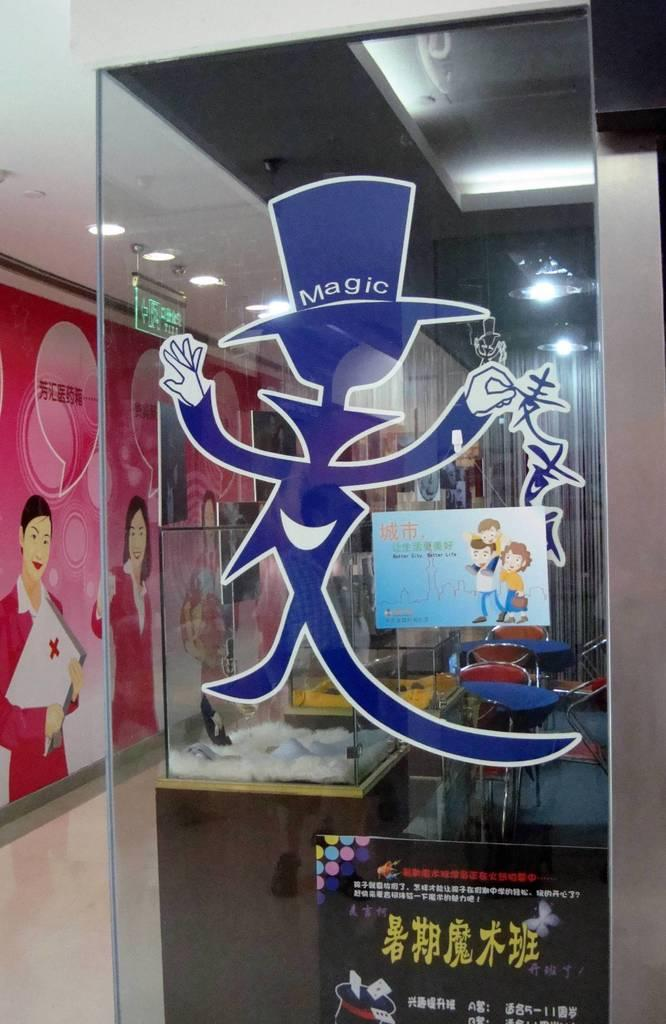<image>
Offer a succinct explanation of the picture presented. A glass panel with a blue magician on the front of it with Magic written on his hat. 